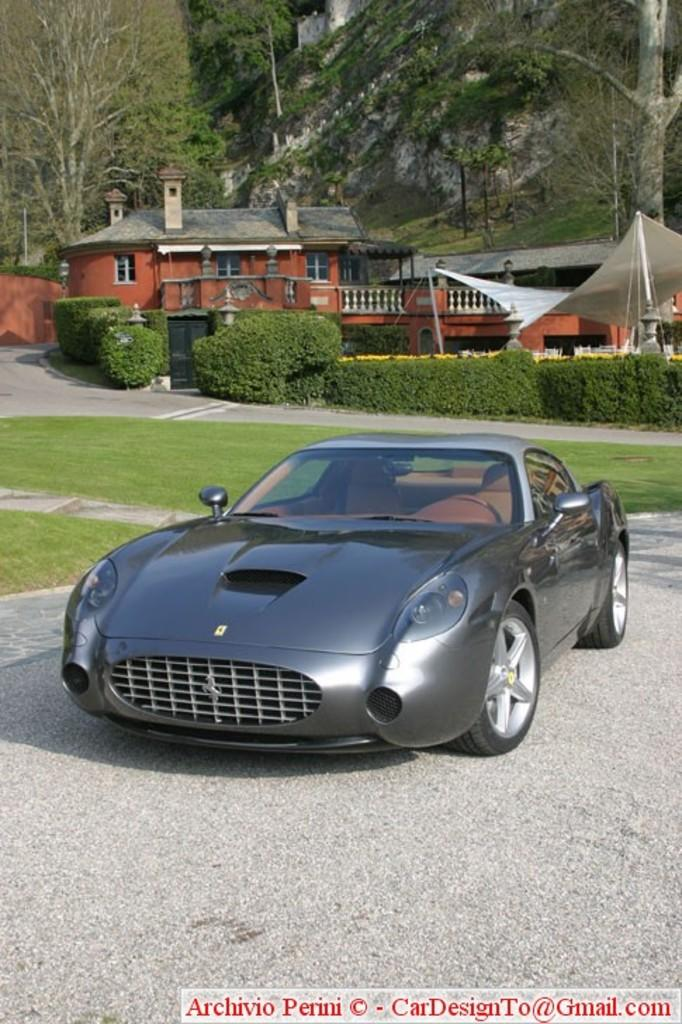What is the main subject of the image? There is a car on the road in the image. What can be seen beside the road? There is grassland beside the road. What type of vegetation is present on the grassland? There are plants on the grassland. What additional structure can be seen in the image? There is a tent in the image. What is visible in the background of the image? There is a house and trees in the background. What type of kitty can be seen playing with a treatment in the image? There is no kitty or treatment present in the image. Is there a camera visible in the image? There is no camera mentioned or visible in the image. 